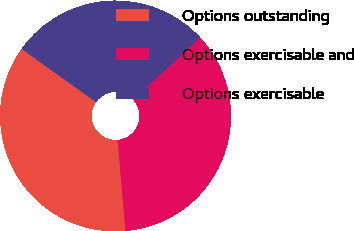<chart> <loc_0><loc_0><loc_500><loc_500><pie_chart><fcel>Options outstanding<fcel>Options exercisable and<fcel>Options exercisable<nl><fcel>36.25%<fcel>35.52%<fcel>28.23%<nl></chart> 